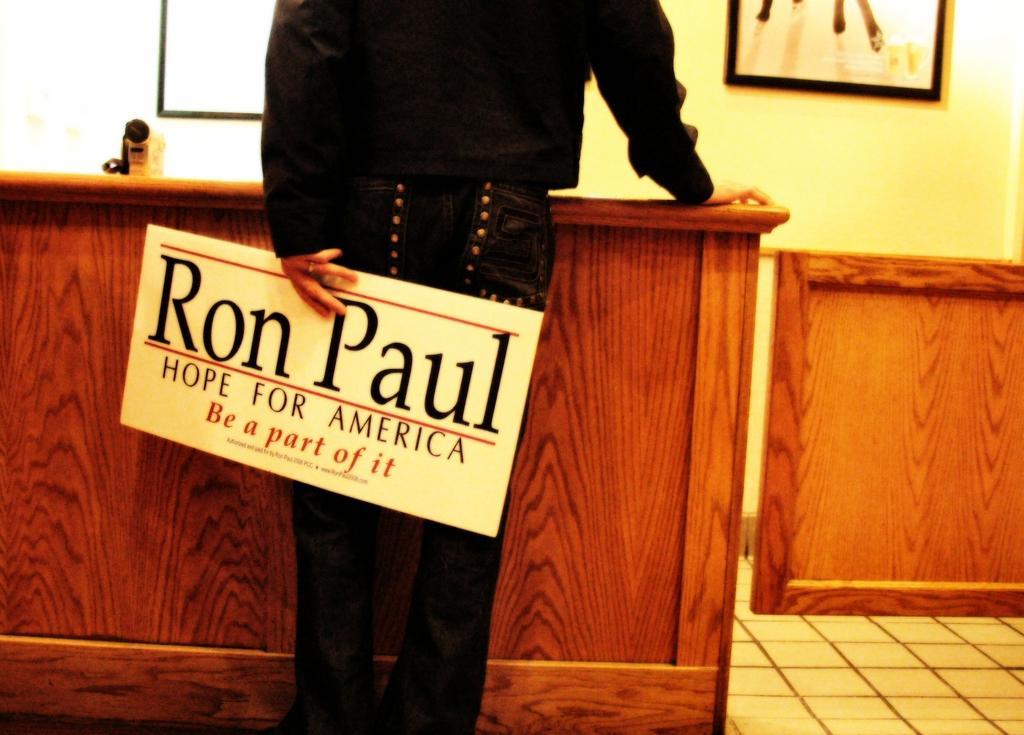How would you summarize this image in a sentence or two? In this image we can see a person holding a board, in front of the person there is a table. On the table there is an object. In the background of the image there is a photo frame attached to the wall. 